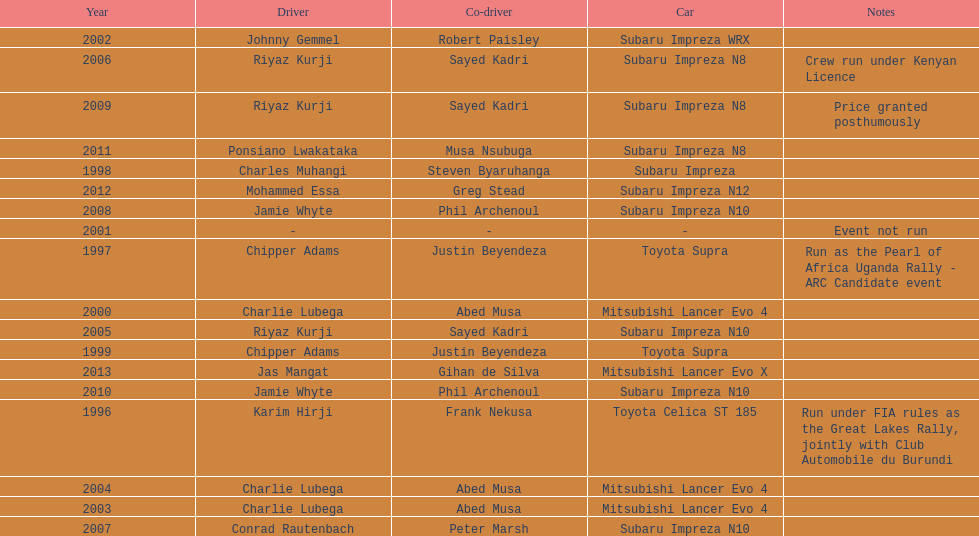Which driver won after ponsiano lwakataka? Mohammed Essa. 